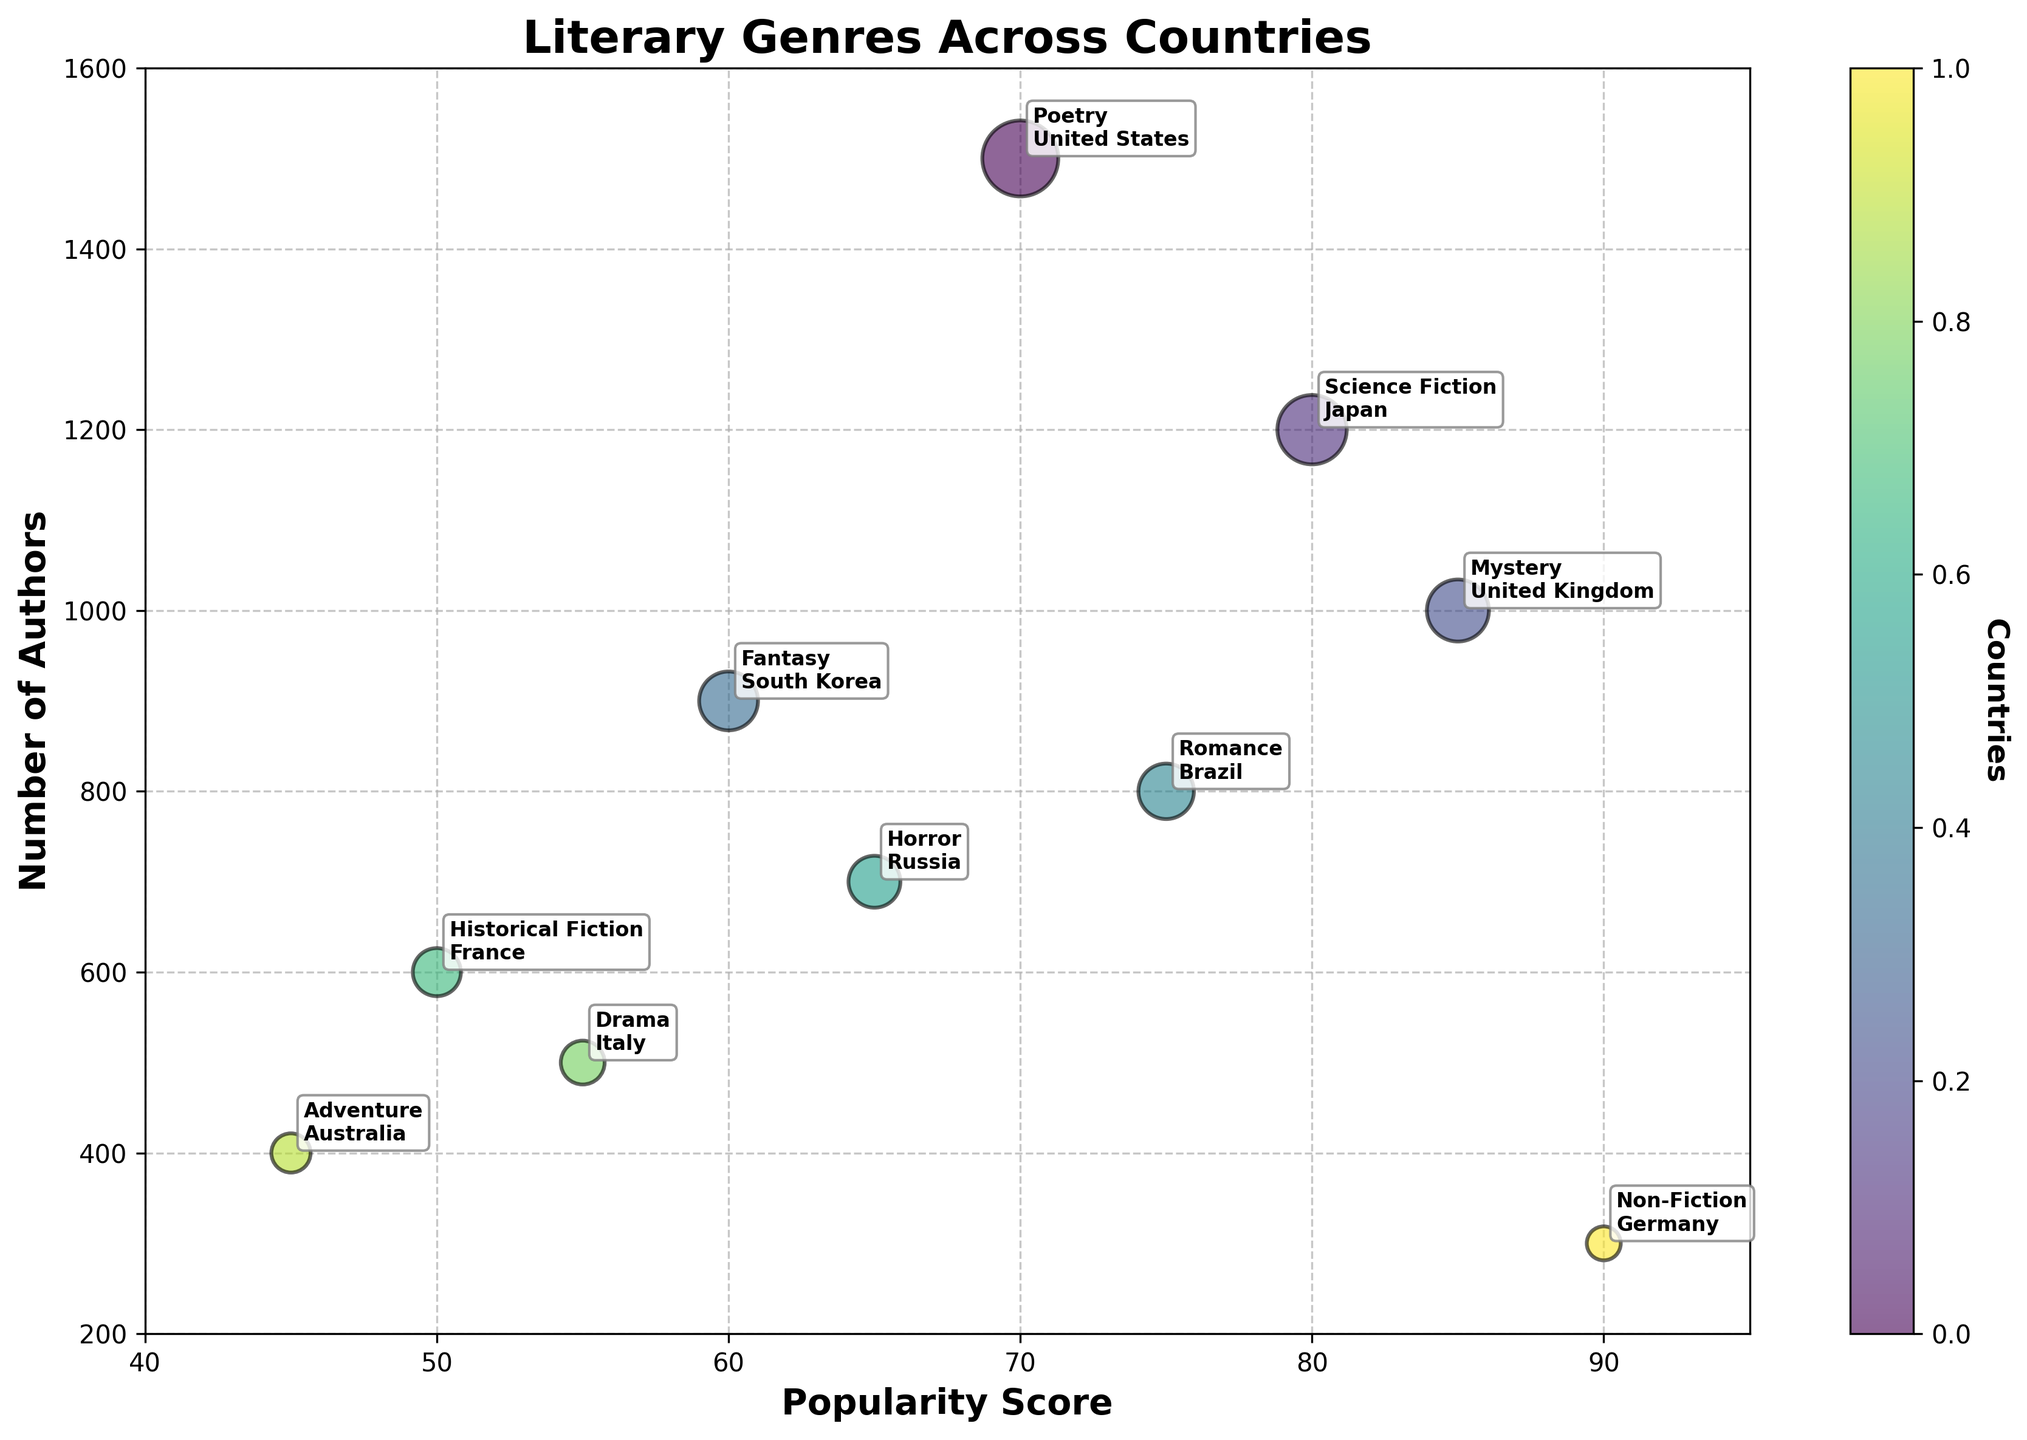What's the title of the bubble chart? The title of the bubble chart is displayed prominently at the top of the figure. It provides a summary of what the chart represents.
Answer: Literary Genres Across Countries What are the x-axis and y-axis labeled as? The labels of both axes are shown clearly on the figure. The x-axis represents the "Popularity Score," and the y-axis represents the "Number of Authors."
Answer: Popularity Score and Number of Authors How many different literary genres are represented in the chart? Count the individual bubbles on the chart, as each bubble represents a different literary genre. There are 10 different bubbles, hence 10 genres.
Answer: 10 Which literary genre has the highest popularity score? Look at the bubble that is farthest to the right on the x-axis, as the highest popularity score will be the largest value on this axis. The genre is "Non-Fiction" from Germany with a score of 90.
Answer: Non-Fiction Which country has the smallest number of authors for any genre? Identify the bubble that is the lowest on the y-axis, as this represents the smallest number of authors. The country is Germany for the genre "Non-Fiction," with 300 authors.
Answer: Germany Which two genres have the closest number of authors? Compare the y-axis positions of the bubbles to find two that are vertically closest. The bubbles for "Horror" in Russia with 700 authors and "Romance" in Brazil with 800 authors are the closest.
Answer: Horror and Romance What is the bubble size of the "Drama" genre, and what does it represent? Locate the "Drama" bubble on the chart, annotated with the country "Italy." Look at the given data for "Drama" to find its BubbleSize, which is 100. This size represents the scaled metric given in the dataset.
Answer: 100 (scaled metric) How does the popularity of "Science Fiction" in Japan compare to "Fantasy" in South Korea? Compare their positions along the x-axis. "Science Fiction" in Japan has a popularity score of 80, while "Fantasy" in South Korea has a score of 60, making "Science Fiction" more popular.
Answer: Science Fiction is more popular than Fantasy Which bubble represents a genre from Brazil, and what are its features on the chart? Look for the annotation indicating "Brazil" on the chart. The bubble is "Romance," with a popularity score of 75, 800 authors, and a bubble size of 160 (scaled).
Answer: Romance; Pop: 75, Authors: 800, Size: 160 What insights can you gain about genres in France and Italy based on their positions on the chart? Compare positions of France ("Historical Fiction") and Italy ("Drama"). France has a lower position on the y-axis (600 authors) and lower on the x-axis (Popularity Score 50) compared to Italy with 500 authors and a Popularity Score of 55. Thus, Historical Fiction in France has slightly more authors and is slightly less popular than Drama in Italy.
Answer: Historical Fiction has more authors but is less popular than Drama 